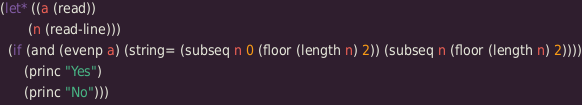<code> <loc_0><loc_0><loc_500><loc_500><_Lisp_>(let* ((a (read))
       (n (read-line)))
  (if (and (evenp a) (string= (subseq n 0 (floor (length n) 2)) (subseq n (floor (length n) 2))))
      (princ "Yes")
      (princ "No")))</code> 